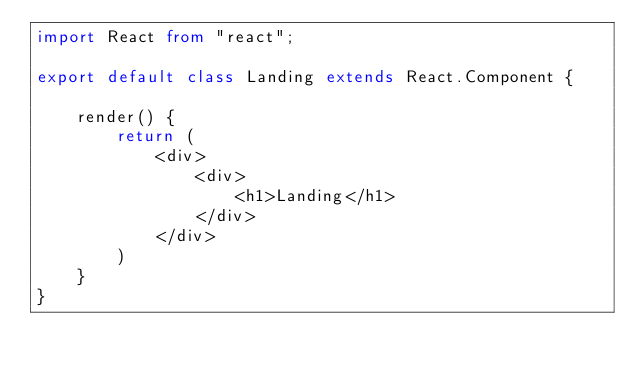Convert code to text. <code><loc_0><loc_0><loc_500><loc_500><_TypeScript_>import React from "react";

export default class Landing extends React.Component {

    render() {
        return (
            <div>
                <div>
                    <h1>Landing</h1>
                </div>
            </div>
        )
    }
}</code> 